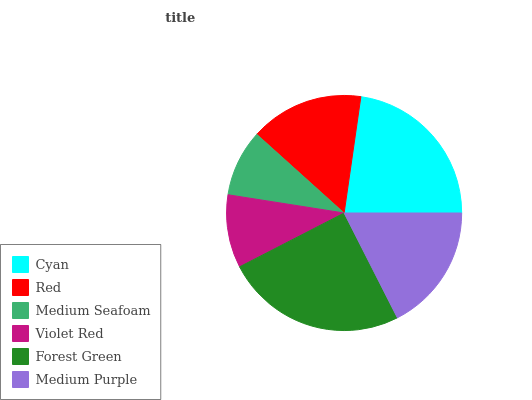Is Medium Seafoam the minimum?
Answer yes or no. Yes. Is Forest Green the maximum?
Answer yes or no. Yes. Is Red the minimum?
Answer yes or no. No. Is Red the maximum?
Answer yes or no. No. Is Cyan greater than Red?
Answer yes or no. Yes. Is Red less than Cyan?
Answer yes or no. Yes. Is Red greater than Cyan?
Answer yes or no. No. Is Cyan less than Red?
Answer yes or no. No. Is Medium Purple the high median?
Answer yes or no. Yes. Is Red the low median?
Answer yes or no. Yes. Is Forest Green the high median?
Answer yes or no. No. Is Forest Green the low median?
Answer yes or no. No. 